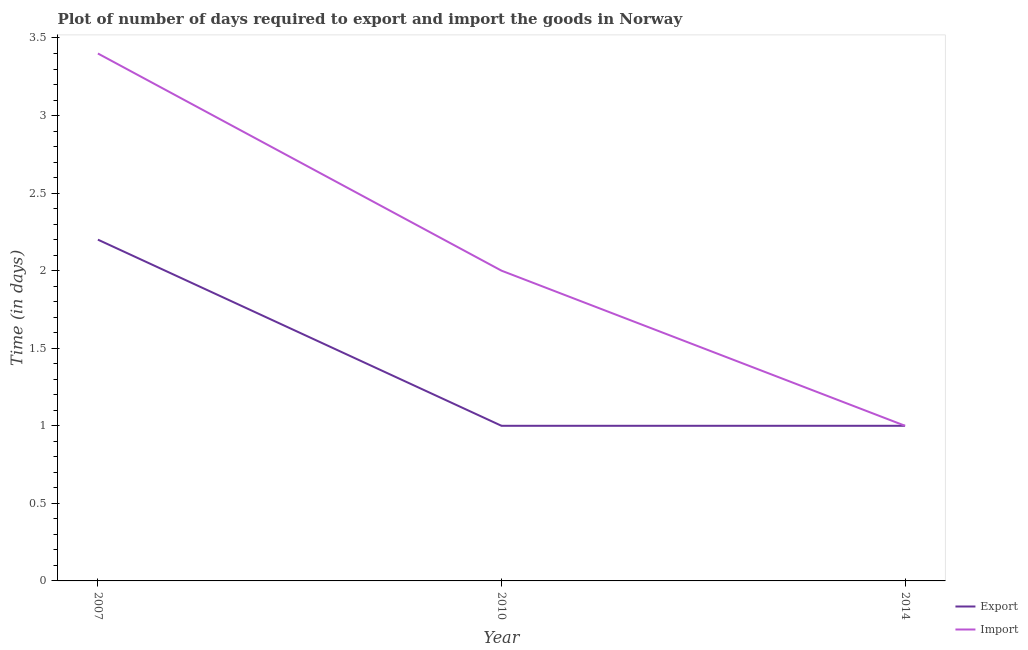How many different coloured lines are there?
Make the answer very short. 2. Does the line corresponding to time required to import intersect with the line corresponding to time required to export?
Your answer should be very brief. Yes. Is the number of lines equal to the number of legend labels?
Provide a short and direct response. Yes. In which year was the time required to import maximum?
Provide a succinct answer. 2007. In which year was the time required to import minimum?
Keep it short and to the point. 2014. What is the total time required to import in the graph?
Your answer should be compact. 6.4. What is the difference between the time required to export in 2014 and the time required to import in 2010?
Provide a short and direct response. -1. What is the average time required to import per year?
Provide a succinct answer. 2.13. In the year 2007, what is the difference between the time required to import and time required to export?
Give a very brief answer. 1.2. In how many years, is the time required to export greater than 1.6 days?
Provide a succinct answer. 1. What is the ratio of the time required to import in 2007 to that in 2010?
Offer a very short reply. 1.7. Is the difference between the time required to import in 2007 and 2010 greater than the difference between the time required to export in 2007 and 2010?
Your answer should be very brief. Yes. What is the difference between the highest and the second highest time required to import?
Your answer should be compact. 1.4. What is the difference between the highest and the lowest time required to import?
Ensure brevity in your answer.  2.4. Is the time required to export strictly greater than the time required to import over the years?
Your answer should be compact. No. What is the difference between two consecutive major ticks on the Y-axis?
Your answer should be compact. 0.5. Are the values on the major ticks of Y-axis written in scientific E-notation?
Your response must be concise. No. Does the graph contain grids?
Give a very brief answer. No. How many legend labels are there?
Keep it short and to the point. 2. How are the legend labels stacked?
Your response must be concise. Vertical. What is the title of the graph?
Your response must be concise. Plot of number of days required to export and import the goods in Norway. What is the label or title of the Y-axis?
Ensure brevity in your answer.  Time (in days). What is the Time (in days) in Import in 2007?
Keep it short and to the point. 3.4. What is the Time (in days) of Export in 2010?
Provide a succinct answer. 1. What is the Time (in days) of Export in 2014?
Make the answer very short. 1. Across all years, what is the maximum Time (in days) of Import?
Offer a terse response. 3.4. Across all years, what is the minimum Time (in days) in Import?
Offer a terse response. 1. What is the total Time (in days) of Export in the graph?
Your response must be concise. 4.2. What is the total Time (in days) of Import in the graph?
Keep it short and to the point. 6.4. What is the difference between the Time (in days) in Export in 2007 and that in 2010?
Provide a short and direct response. 1.2. What is the difference between the Time (in days) of Import in 2007 and that in 2010?
Offer a very short reply. 1.4. What is the difference between the Time (in days) in Export in 2007 and that in 2014?
Your response must be concise. 1.2. What is the difference between the Time (in days) of Import in 2007 and that in 2014?
Make the answer very short. 2.4. What is the difference between the Time (in days) of Export in 2010 and that in 2014?
Keep it short and to the point. 0. What is the difference between the Time (in days) of Import in 2010 and that in 2014?
Provide a succinct answer. 1. What is the average Time (in days) of Export per year?
Make the answer very short. 1.4. What is the average Time (in days) of Import per year?
Your answer should be very brief. 2.13. In the year 2014, what is the difference between the Time (in days) of Export and Time (in days) of Import?
Your response must be concise. 0. What is the ratio of the Time (in days) in Export in 2007 to that in 2010?
Offer a terse response. 2.2. What is the ratio of the Time (in days) in Import in 2007 to that in 2010?
Keep it short and to the point. 1.7. What is the ratio of the Time (in days) of Import in 2010 to that in 2014?
Your answer should be very brief. 2. What is the difference between the highest and the second highest Time (in days) of Export?
Give a very brief answer. 1.2. What is the difference between the highest and the second highest Time (in days) of Import?
Your answer should be compact. 1.4. What is the difference between the highest and the lowest Time (in days) in Import?
Keep it short and to the point. 2.4. 